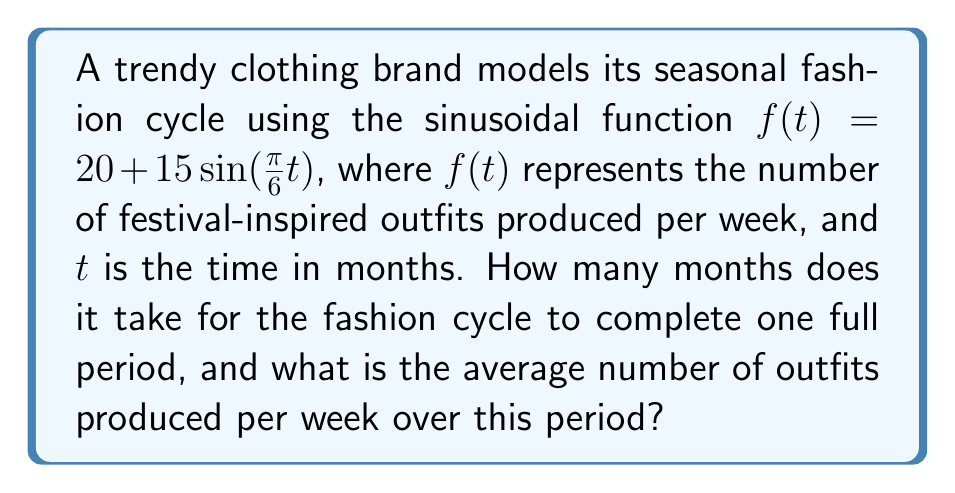Could you help me with this problem? To solve this problem, we need to analyze the given sinusoidal function:

$f(t) = 20 + 15\sin(\frac{\pi}{6}t)$

Step 1: Determine the period of the function.
For a sinusoidal function in the form $a\sin(bt)$, the period is given by $\frac{2\pi}{|b|}$.
In this case, $b = \frac{\pi}{6}$, so the period is:

$\text{Period} = \frac{2\pi}{|\frac{\pi}{6}|} = \frac{2\pi}{\frac{\pi}{6}} = 2 \cdot 6 = 12$ months

Step 2: Calculate the average number of outfits produced per week.
The average value of a sinusoidal function over one complete period is equal to its vertical shift. In this case, the vertical shift is 20.

Therefore, the average number of outfits produced per week is 20.
Answer: 12 months; 20 outfits/week 